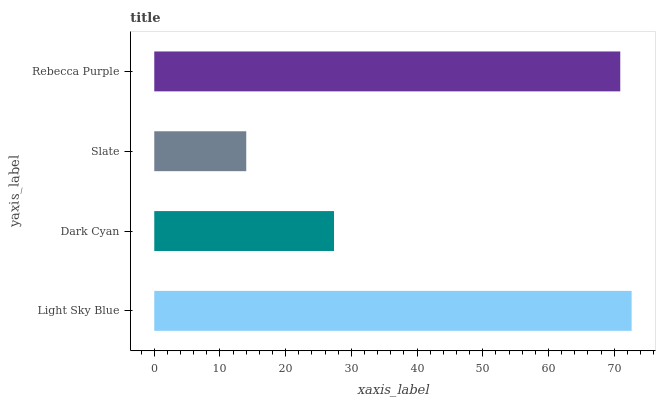Is Slate the minimum?
Answer yes or no. Yes. Is Light Sky Blue the maximum?
Answer yes or no. Yes. Is Dark Cyan the minimum?
Answer yes or no. No. Is Dark Cyan the maximum?
Answer yes or no. No. Is Light Sky Blue greater than Dark Cyan?
Answer yes or no. Yes. Is Dark Cyan less than Light Sky Blue?
Answer yes or no. Yes. Is Dark Cyan greater than Light Sky Blue?
Answer yes or no. No. Is Light Sky Blue less than Dark Cyan?
Answer yes or no. No. Is Rebecca Purple the high median?
Answer yes or no. Yes. Is Dark Cyan the low median?
Answer yes or no. Yes. Is Slate the high median?
Answer yes or no. No. Is Slate the low median?
Answer yes or no. No. 